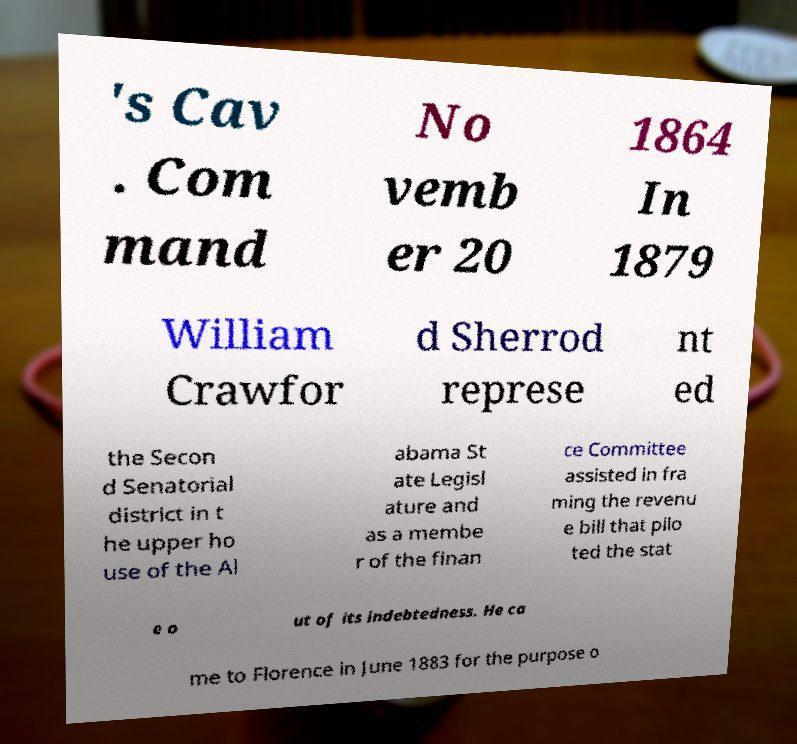What messages or text are displayed in this image? I need them in a readable, typed format. 's Cav . Com mand No vemb er 20 1864 In 1879 William Crawfor d Sherrod represe nt ed the Secon d Senatorial district in t he upper ho use of the Al abama St ate Legisl ature and as a membe r of the finan ce Committee assisted in fra ming the revenu e bill that pilo ted the stat e o ut of its indebtedness. He ca me to Florence in June 1883 for the purpose o 